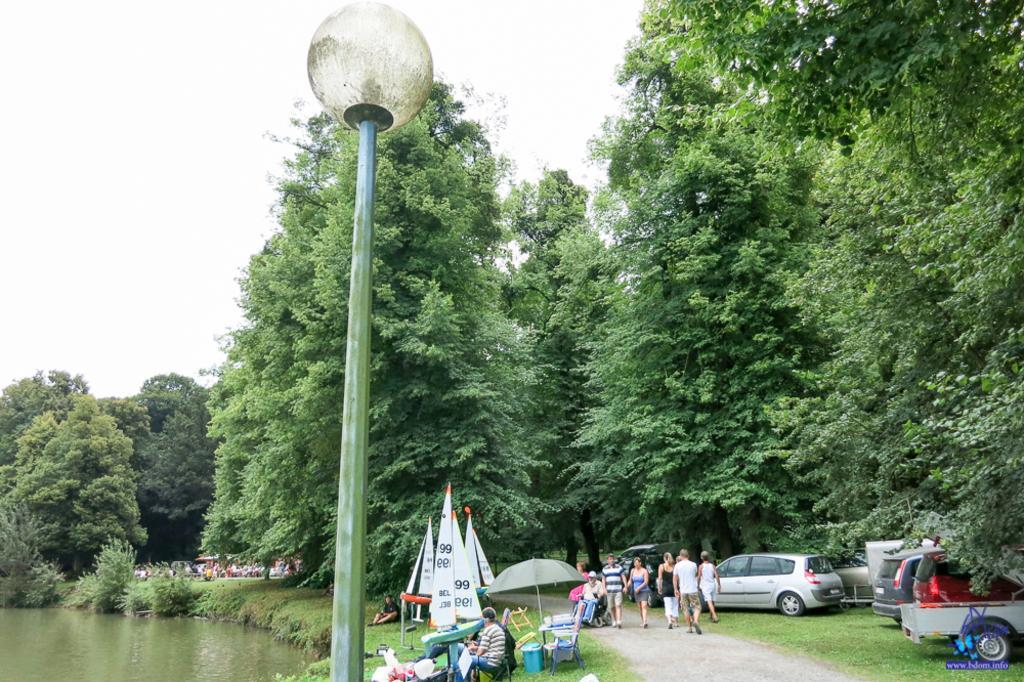Please provide a concise description of this image. In the image there are many trees and under the trees there are few cars and some people are walking on the road, on the left side there are umbrellas, banners and other objects and there is a pond on the left side, there is a pole light in the foreground. 